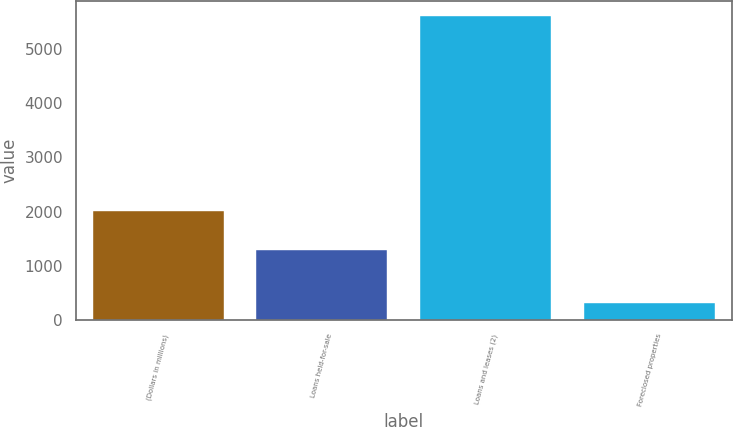Convert chart to OTSL. <chart><loc_0><loc_0><loc_500><loc_500><bar_chart><fcel>(Dollars in millions)<fcel>Loans held-for-sale<fcel>Loans and leases (2)<fcel>Foreclosed properties<nl><fcel>2009<fcel>1288<fcel>5596<fcel>322<nl></chart> 